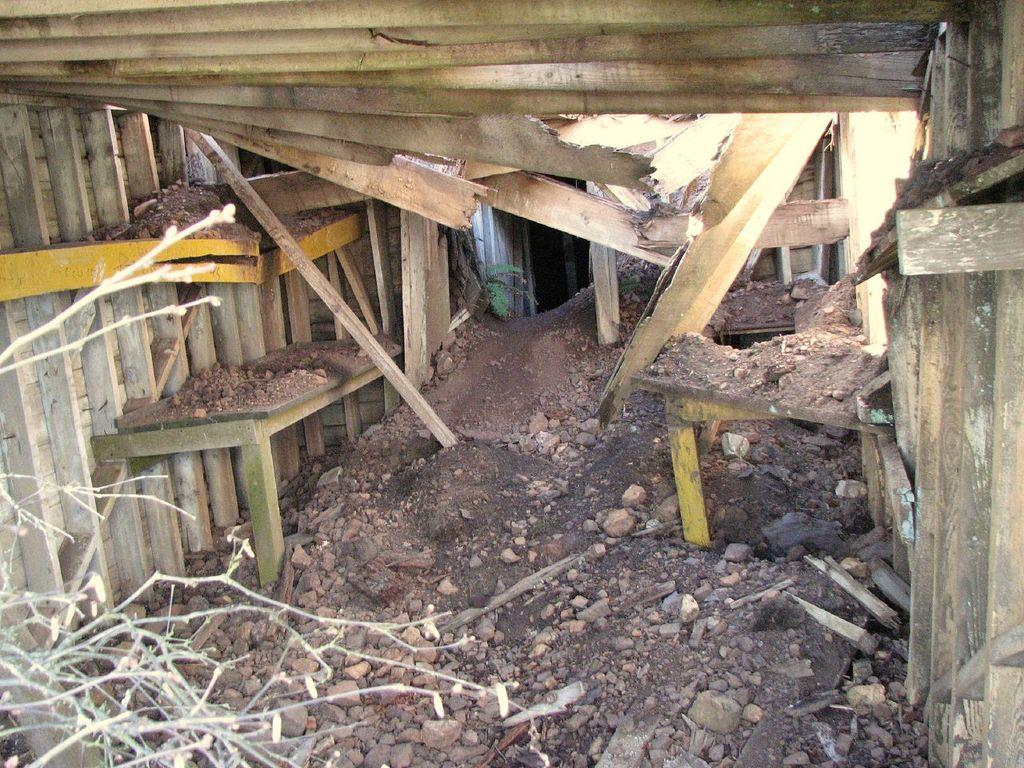What type of objects are made of wood in the image? There are wooden sticks in the image. What type of objects are made of stone in the image? There are stones in the image. What type of structure can be seen in the image? There is a wall in the image. What type of silk material is draped over the wall in the image? There is no silk material present in the image; it only features wooden sticks, stones, and a wall. 